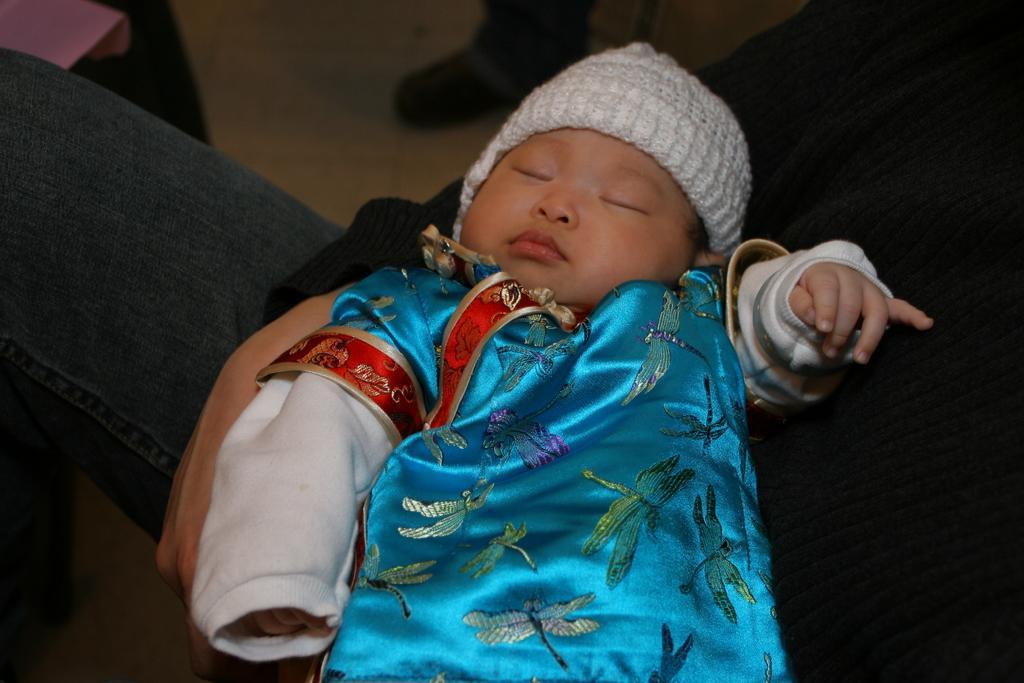Please provide a concise description of this image. In this image I can see a baby sleeping and the baby is wearing blue color dress. I can also see a person sitting. 